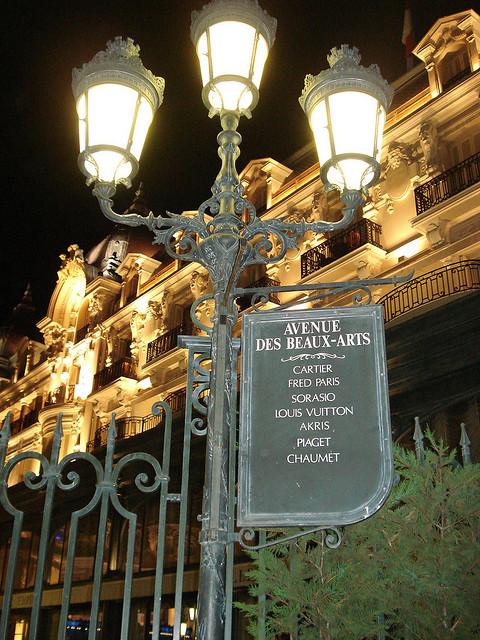What does the sign say?
Quick response, please. Avenue des beaux arts. What kind of lamp post is that?
Keep it brief. Street. How many lights are on the post?
Be succinct. 3. 